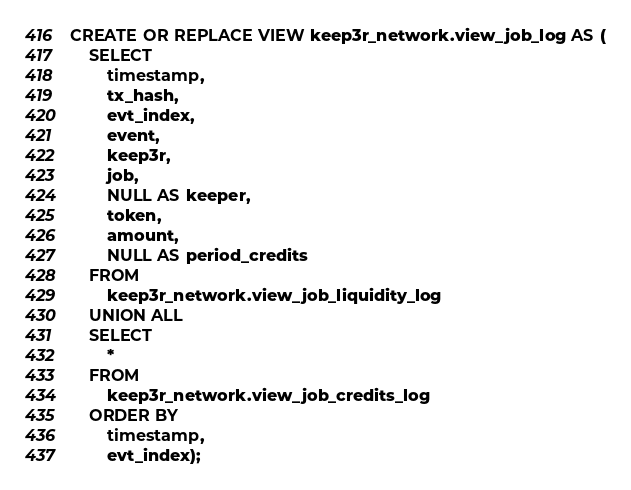<code> <loc_0><loc_0><loc_500><loc_500><_SQL_>CREATE OR REPLACE VIEW keep3r_network.view_job_log AS (
    SELECT
        timestamp,
        tx_hash,
        evt_index,
        event,
        keep3r,
        job,
        NULL AS keeper,
        token,
        amount,
        NULL AS period_credits
    FROM
        keep3r_network.view_job_liquidity_log
    UNION ALL
    SELECT
        *
    FROM
        keep3r_network.view_job_credits_log
    ORDER BY
        timestamp,
        evt_index);
</code> 